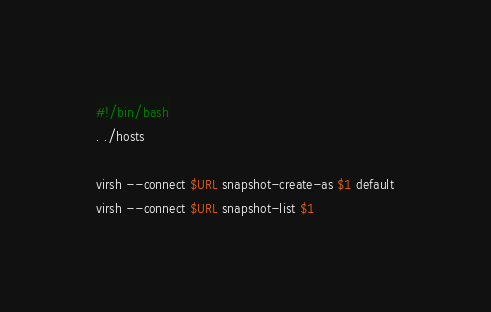Convert code to text. <code><loc_0><loc_0><loc_500><loc_500><_Bash_>#!/bin/bash
. ./hosts

virsh --connect $URL snapshot-create-as $1 default
virsh --connect $URL snapshot-list $1
</code> 